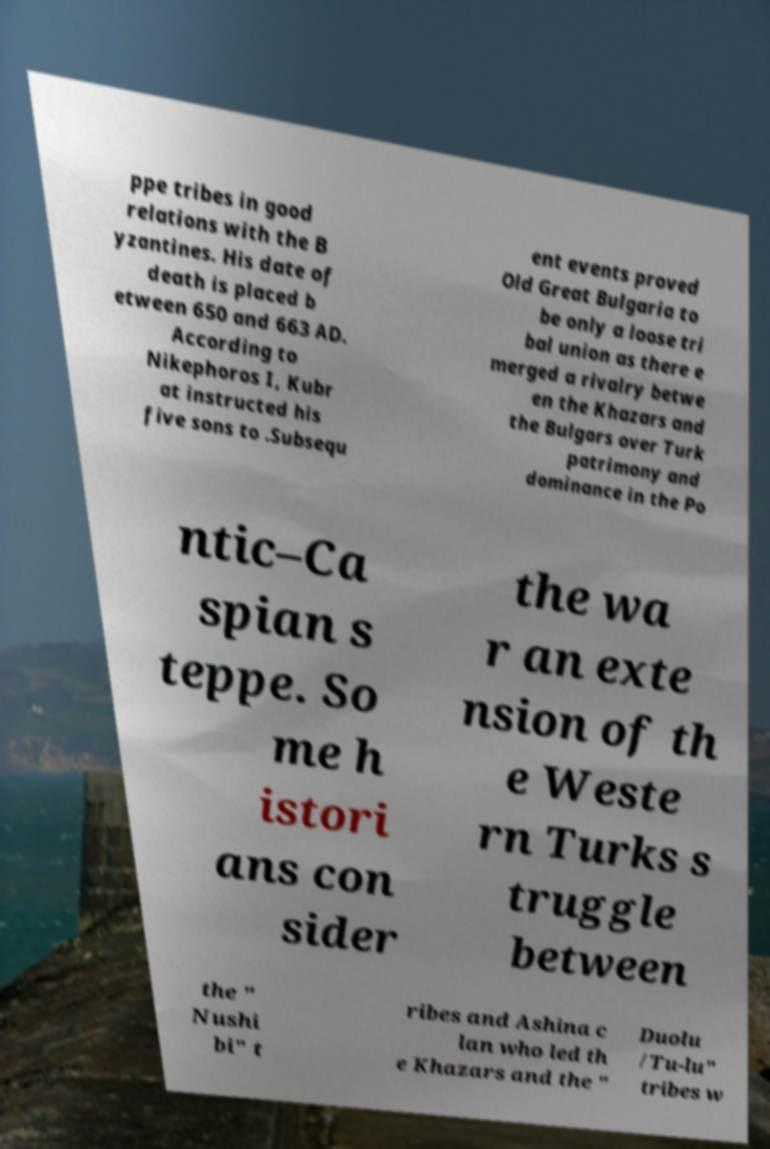For documentation purposes, I need the text within this image transcribed. Could you provide that? ppe tribes in good relations with the B yzantines. His date of death is placed b etween 650 and 663 AD. According to Nikephoros I, Kubr at instructed his five sons to .Subsequ ent events proved Old Great Bulgaria to be only a loose tri bal union as there e merged a rivalry betwe en the Khazars and the Bulgars over Turk patrimony and dominance in the Po ntic–Ca spian s teppe. So me h istori ans con sider the wa r an exte nsion of th e Weste rn Turks s truggle between the " Nushi bi" t ribes and Ashina c lan who led th e Khazars and the " Duolu /Tu-lu" tribes w 